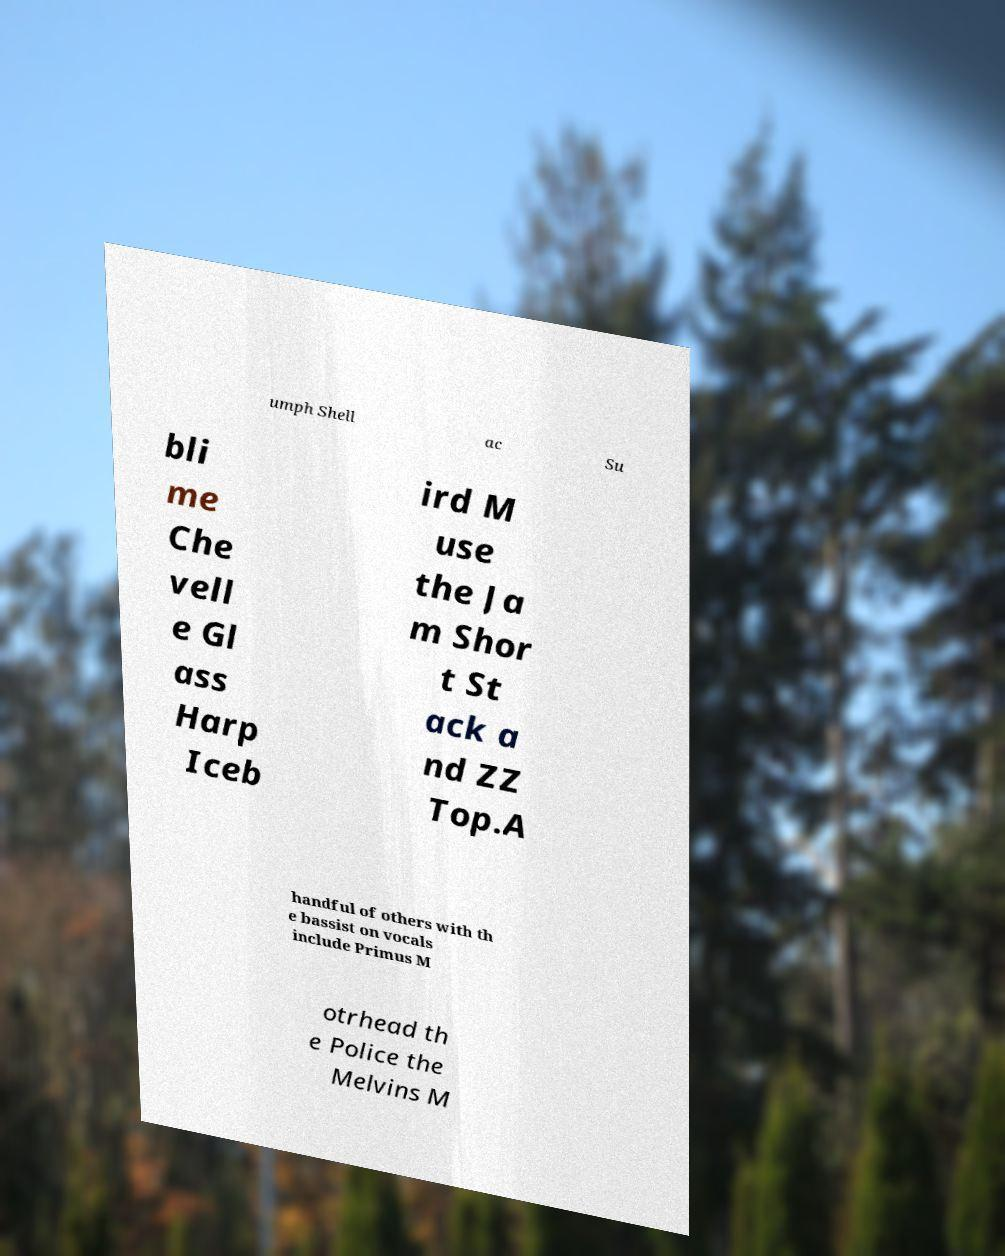Can you read and provide the text displayed in the image?This photo seems to have some interesting text. Can you extract and type it out for me? umph Shell ac Su bli me Che vell e Gl ass Harp Iceb ird M use the Ja m Shor t St ack a nd ZZ Top.A handful of others with th e bassist on vocals include Primus M otrhead th e Police the Melvins M 